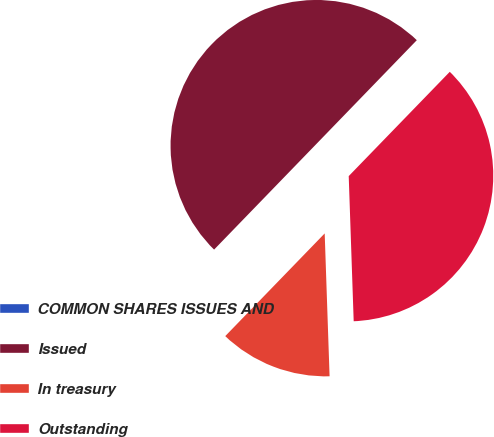Convert chart. <chart><loc_0><loc_0><loc_500><loc_500><pie_chart><fcel>COMMON SHARES ISSUES AND<fcel>Issued<fcel>In treasury<fcel>Outstanding<nl><fcel>0.01%<fcel>50.0%<fcel>12.79%<fcel>37.21%<nl></chart> 